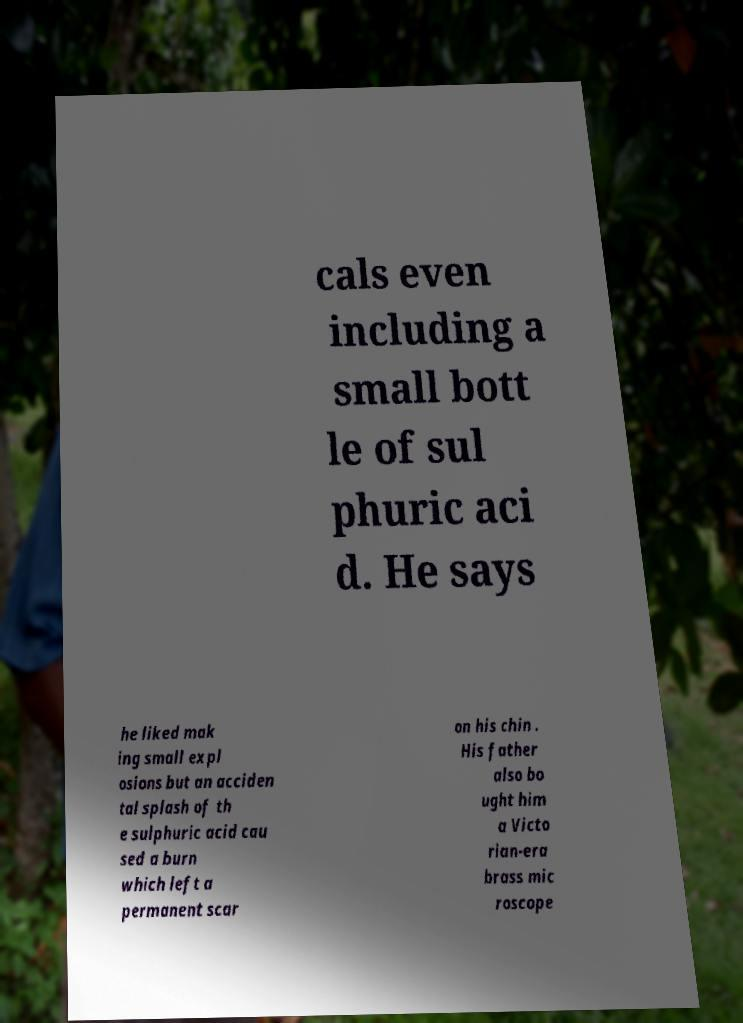Could you extract and type out the text from this image? cals even including a small bott le of sul phuric aci d. He says he liked mak ing small expl osions but an acciden tal splash of th e sulphuric acid cau sed a burn which left a permanent scar on his chin . His father also bo ught him a Victo rian-era brass mic roscope 